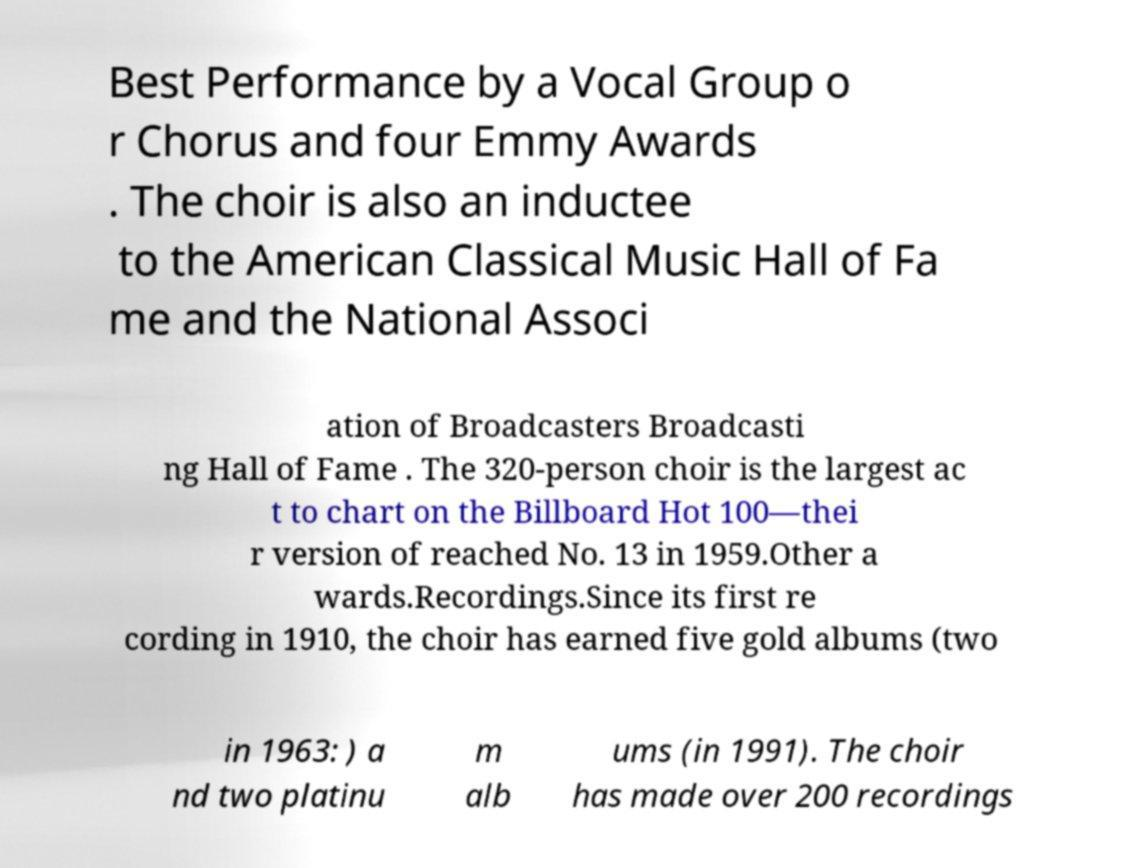Could you assist in decoding the text presented in this image and type it out clearly? Best Performance by a Vocal Group o r Chorus and four Emmy Awards . The choir is also an inductee to the American Classical Music Hall of Fa me and the National Associ ation of Broadcasters Broadcasti ng Hall of Fame . The 320-person choir is the largest ac t to chart on the Billboard Hot 100—thei r version of reached No. 13 in 1959.Other a wards.Recordings.Since its first re cording in 1910, the choir has earned five gold albums (two in 1963: ) a nd two platinu m alb ums (in 1991). The choir has made over 200 recordings 